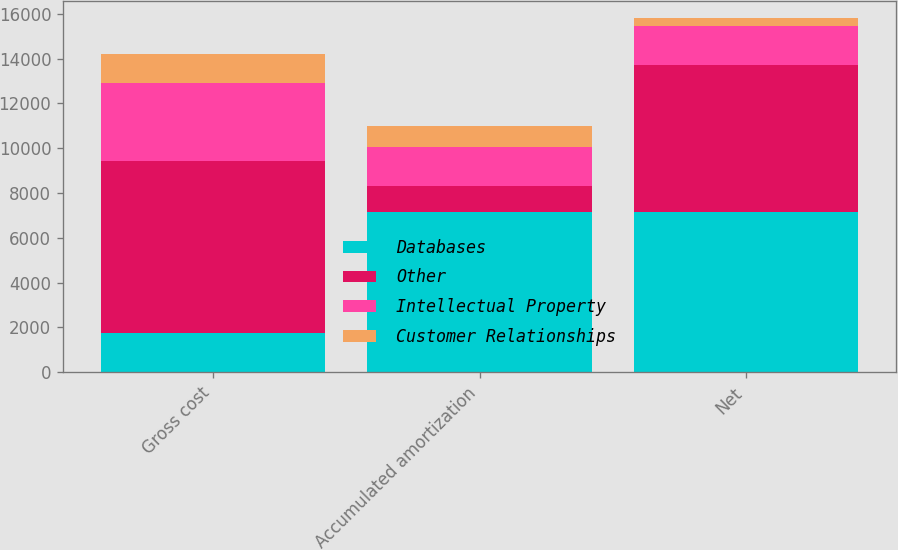Convert chart to OTSL. <chart><loc_0><loc_0><loc_500><loc_500><stacked_bar_chart><ecel><fcel>Gross cost<fcel>Accumulated amortization<fcel>Net<nl><fcel>Databases<fcel>1740<fcel>7158<fcel>7159<nl><fcel>Other<fcel>7700<fcel>1155<fcel>6545<nl><fcel>Intellectual Property<fcel>3479<fcel>1739<fcel>1740<nl><fcel>Customer Relationships<fcel>1293<fcel>944<fcel>349<nl></chart> 